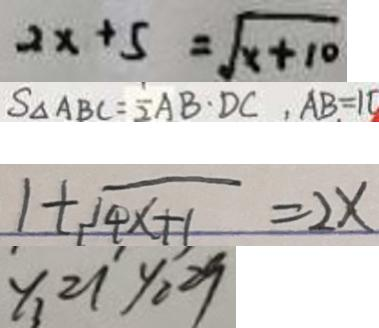<formula> <loc_0><loc_0><loc_500><loc_500>2 x + 5 = \sqrt { x + 1 0 } 
 S _ { \Delta A B C } = \frac { 1 } { 2 } A B \cdot D C , A B = 1 0 
 1 + \sqrt { 4 x + 1 } = 2 x 
 y _ { 1 } = 1 y _ { 2 } = 9</formula> 